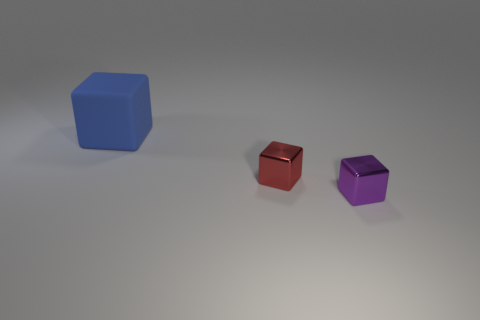Subtract all purple blocks. How many blocks are left? 2 Add 3 large red cylinders. How many objects exist? 6 Subtract all green balls. How many purple blocks are left? 1 Subtract all red cubes. How many cubes are left? 2 Subtract all blue blocks. Subtract all purple balls. How many blocks are left? 2 Add 2 tiny red blocks. How many tiny red blocks exist? 3 Subtract 0 cyan cylinders. How many objects are left? 3 Subtract all cyan rubber balls. Subtract all matte cubes. How many objects are left? 2 Add 2 red objects. How many red objects are left? 3 